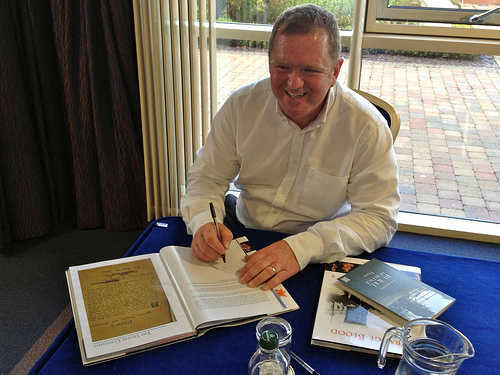<image>
Is the man behind the window? No. The man is not behind the window. From this viewpoint, the man appears to be positioned elsewhere in the scene. Is the pen above the book? Yes. The pen is positioned above the book in the vertical space, higher up in the scene. 